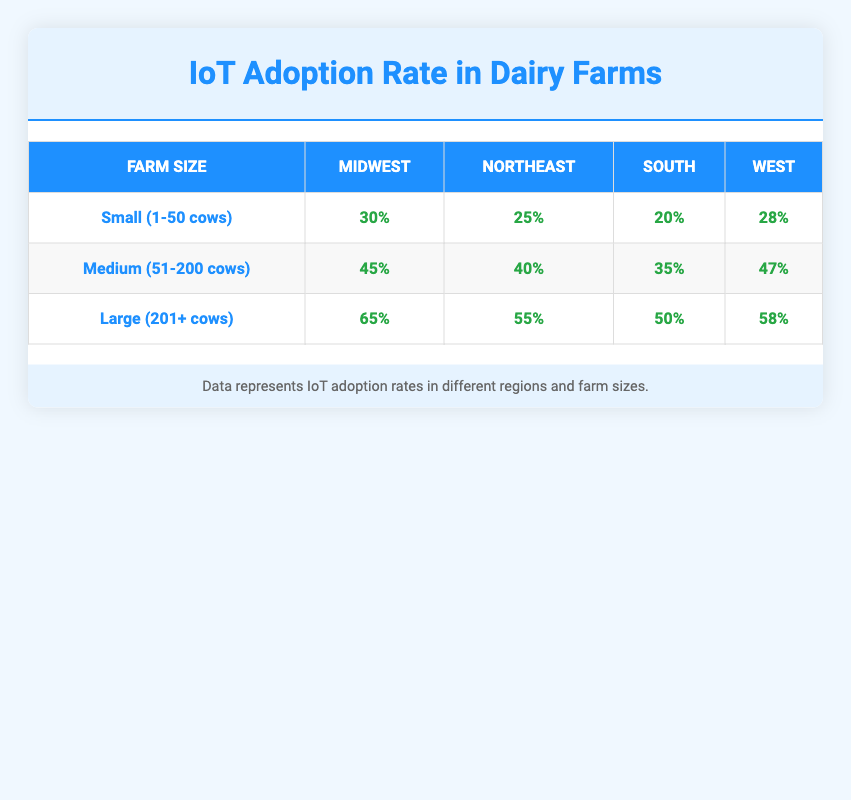What is the adoption rate of small dairy farms in the Midwest? The table shows that the adoption rate for small dairy farms (1-50 cows) in the Midwest is 30%.
Answer: 30% Which region has the highest adoption rate for medium dairy farms? By comparing the adoption rates for medium dairy farms (51-200 cows) across all regions in the table, the Midwest has the highest rate at 45%.
Answer: Midwest What is the average adoption rate for small dairy farms across all regions? To calculate the average, sum the adoption rates for small farms: 30% + 25% + 20% + 28% = 103%. Then divide by 4 (the number of regions), giving an average of 103% / 4 = 25.75%.
Answer: 25.75% Is the adoption rate for large dairy farms in the South higher than in the Northeast? The adoption rate for large dairy farms (201+ cows) in the South is 50%, while in the Northeast it is 55%. Since 50% is not higher than 55%, the answer is no.
Answer: No What is the difference in adoption rates for large dairy farms between the Midwest and the South? The table shows that the adoption rate for large dairy farms in the Midwest is 65%, and in the South, it is 50%. The difference is calculated as 65% - 50% = 15%.
Answer: 15% 